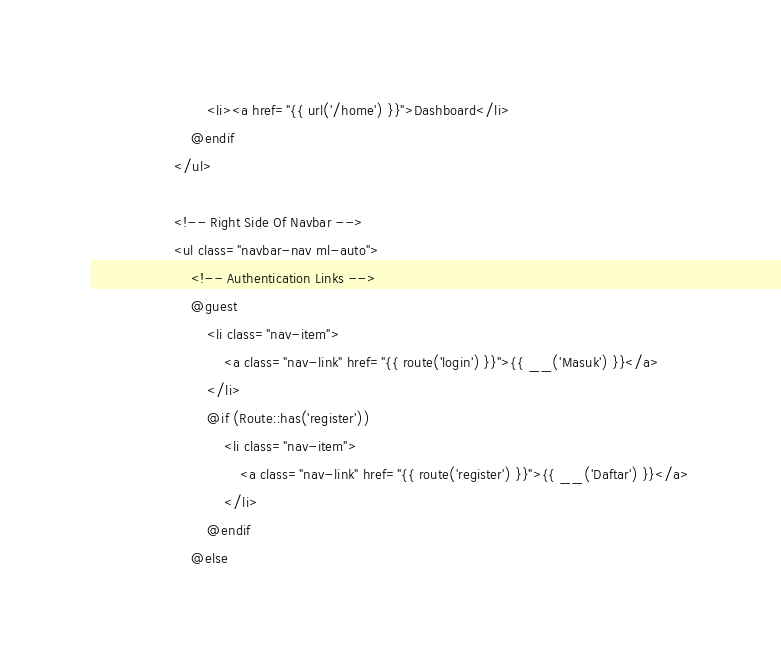<code> <loc_0><loc_0><loc_500><loc_500><_PHP_>                            <li><a href="{{ url('/home') }}">Dashboard</li>
                        @endif
                    </ul>

                    <!-- Right Side Of Navbar -->
                    <ul class="navbar-nav ml-auto">
                        <!-- Authentication Links -->
                        @guest
                            <li class="nav-item">
                                <a class="nav-link" href="{{ route('login') }}">{{ __('Masuk') }}</a>
                            </li>
                            @if (Route::has('register'))
                                <li class="nav-item">
                                    <a class="nav-link" href="{{ route('register') }}">{{ __('Daftar') }}</a>
                                </li>
                            @endif
                        @else</code> 